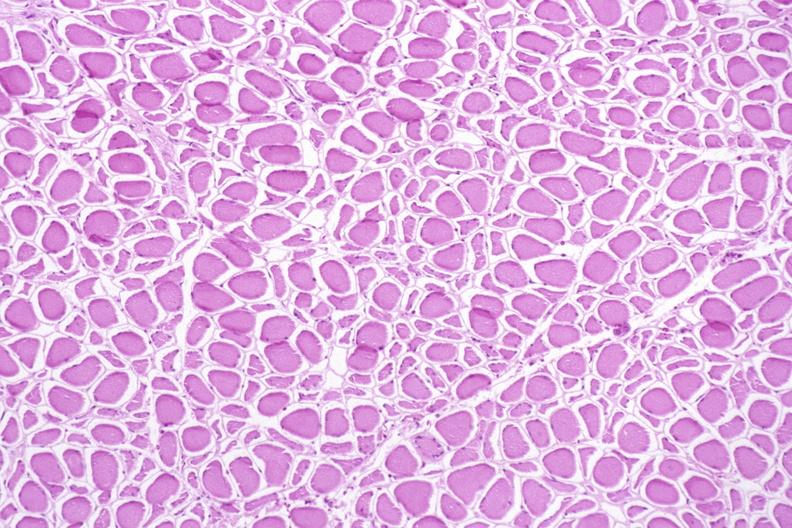why does this image show skeletal muscle, atrophy?
Answer the question using a single word or phrase. Due to immobilization cast 